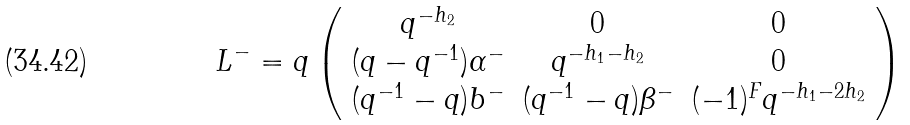Convert formula to latex. <formula><loc_0><loc_0><loc_500><loc_500>L ^ { - } = q \left ( \begin{array} { c c c } q ^ { - h _ { 2 } } & 0 & 0 \\ ( q - q ^ { - 1 } ) \alpha ^ { - } & q ^ { - h _ { 1 } - h _ { 2 } } & 0 \\ ( q ^ { - 1 } - q ) b ^ { - } & ( q ^ { - 1 } - q ) \beta ^ { - } & ( - 1 ) ^ { F } q ^ { - h _ { 1 } - 2 h _ { 2 } } \end{array} \right )</formula> 